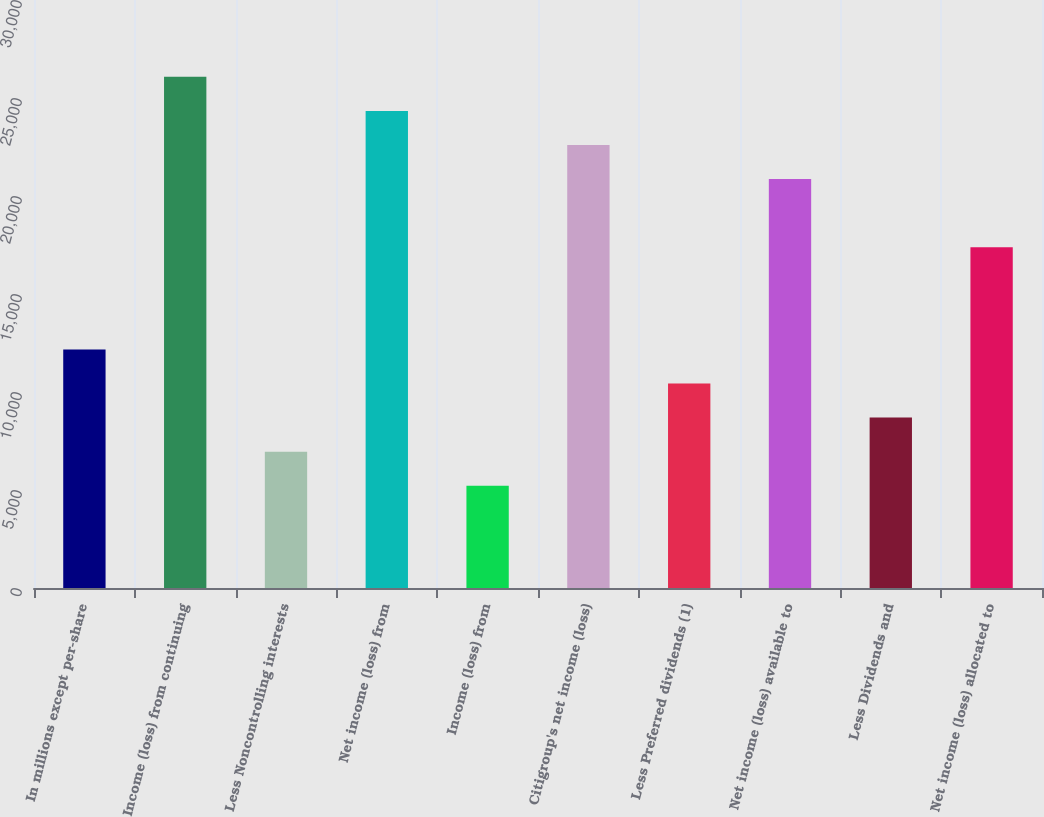<chart> <loc_0><loc_0><loc_500><loc_500><bar_chart><fcel>In millions except per-share<fcel>Income (loss) from continuing<fcel>Less Noncontrolling interests<fcel>Net income (loss) from<fcel>Income (loss) from<fcel>Citigroup's net income (loss)<fcel>Less Preferred dividends (1)<fcel>Net income (loss) available to<fcel>Less Dividends and<fcel>Net income (loss) allocated to<nl><fcel>12170.2<fcel>26079<fcel>6954.42<fcel>24340.4<fcel>5215.82<fcel>22601.8<fcel>10431.6<fcel>20863.2<fcel>8693.02<fcel>17386<nl></chart> 